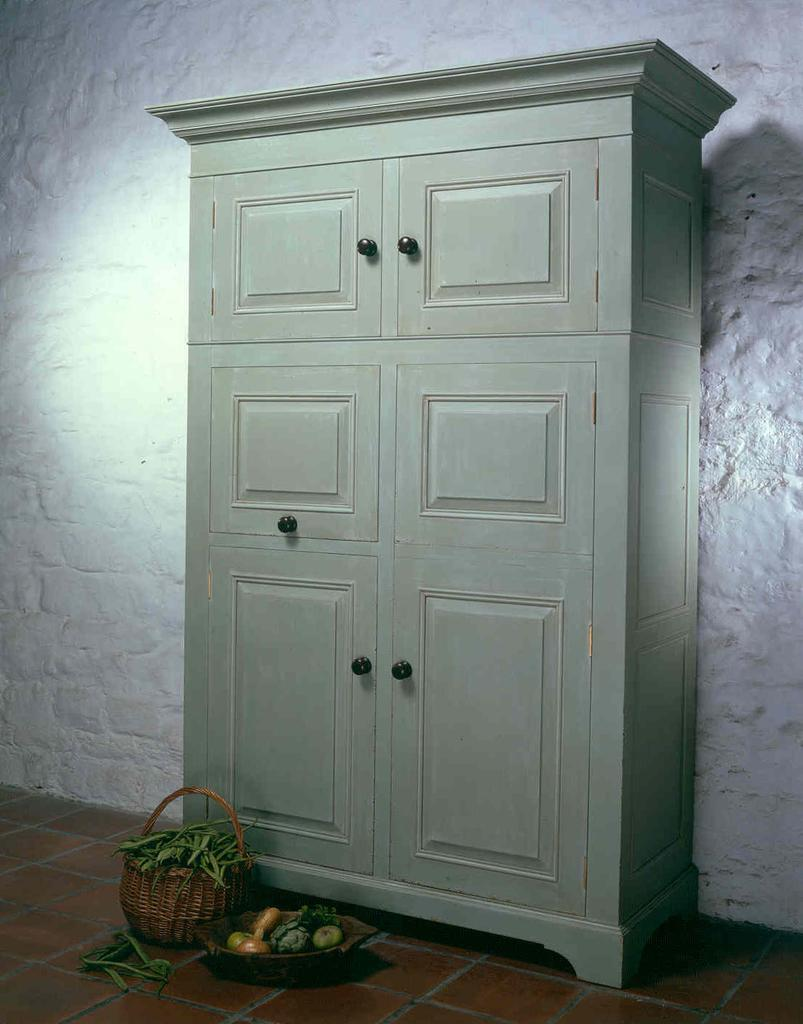What is the color of the wall in the image? The wall in the image is white. What type of furniture is present in the image? There is an almirah in the image. What other object can be seen in the image? There is a basket in the image. What type of items are visible in the image? There are vegetables in the image. What country is depicted in the image? There is no country depicted in the image; it features a white wall, an almirah, a basket, and vegetables. What type of amusement can be seen in the image? There is no amusement present in the image; it features a white wall, an almirah, a basket, and vegetables. 